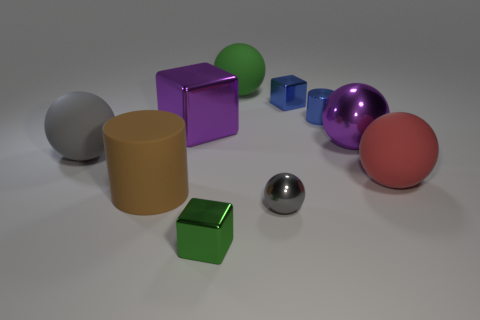Subtract all green balls. How many balls are left? 4 Subtract all brown balls. Subtract all blue cylinders. How many balls are left? 5 Subtract all cylinders. How many objects are left? 8 Subtract all small red metallic blocks. Subtract all big gray balls. How many objects are left? 9 Add 2 purple metallic things. How many purple metallic things are left? 4 Add 3 green balls. How many green balls exist? 4 Subtract 2 gray balls. How many objects are left? 8 